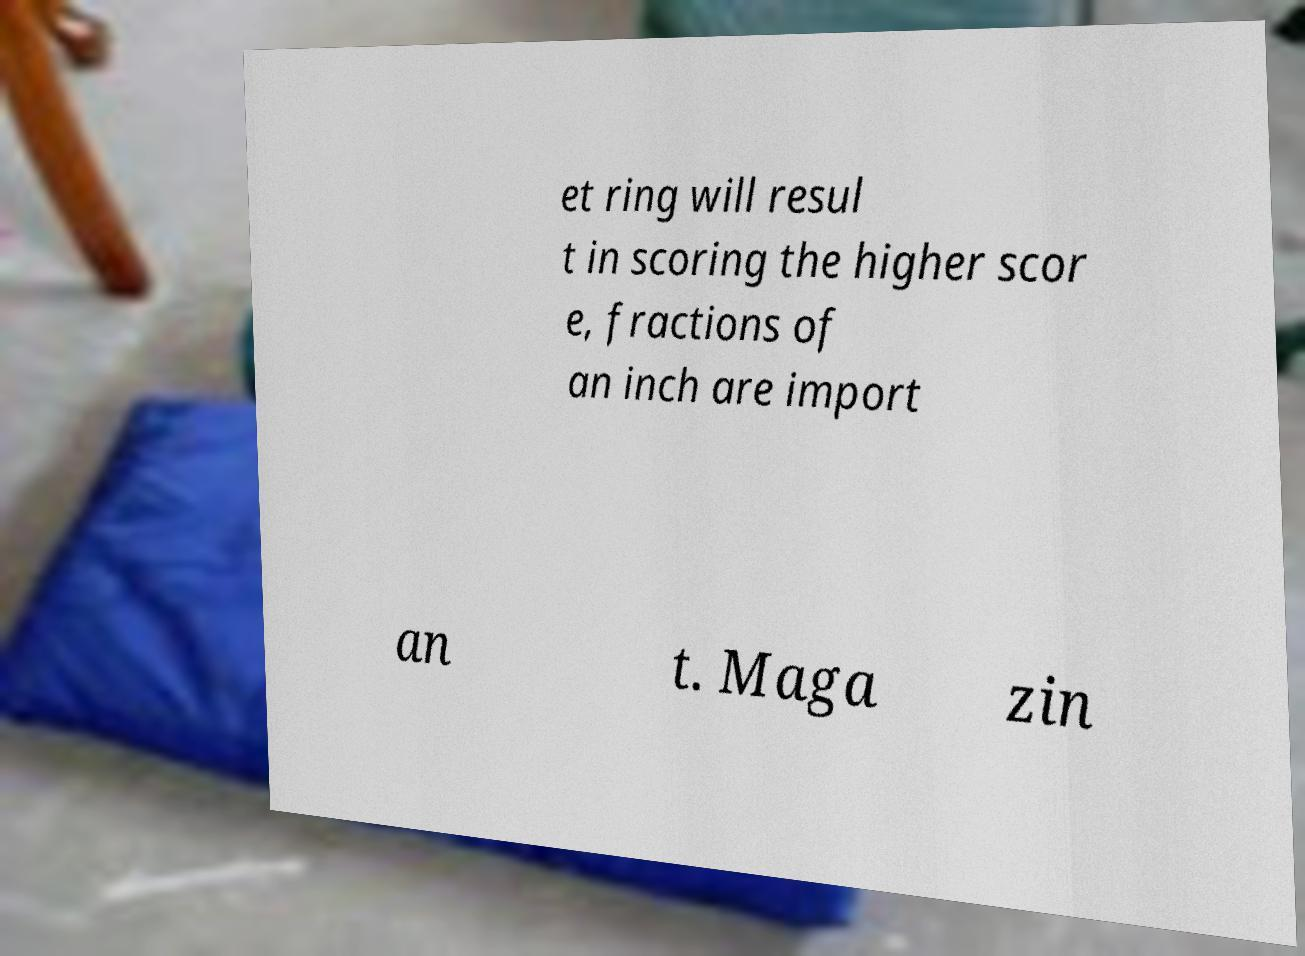Could you assist in decoding the text presented in this image and type it out clearly? et ring will resul t in scoring the higher scor e, fractions of an inch are import an t. Maga zin 